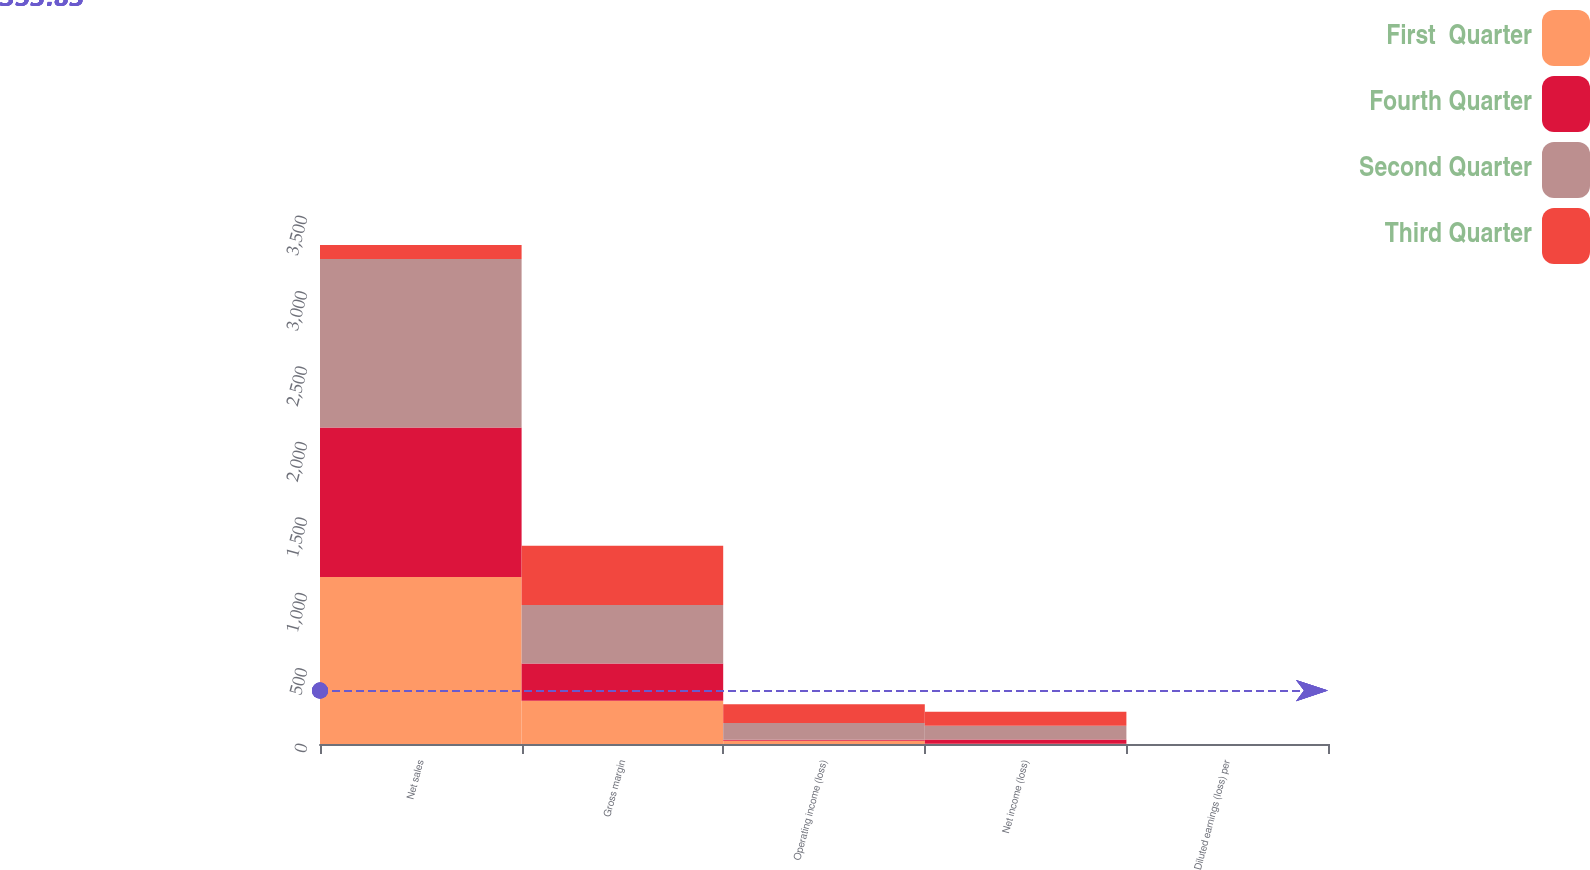<chart> <loc_0><loc_0><loc_500><loc_500><stacked_bar_chart><ecel><fcel>Net sales<fcel>Gross margin<fcel>Operating income (loss)<fcel>Net income (loss)<fcel>Diluted earnings (loss) per<nl><fcel>First  Quarter<fcel>1107.2<fcel>286<fcel>21.7<fcel>1.1<fcel>0<nl><fcel>Fourth Quarter<fcel>991<fcel>248.2<fcel>7.1<fcel>28.3<fcel>0.04<nl><fcel>Second Quarter<fcel>1116.8<fcel>387.9<fcel>109.7<fcel>90.9<fcel>0.13<nl><fcel>Third Quarter<fcel>93.5<fcel>392.6<fcel>125.4<fcel>93.5<fcel>0.14<nl></chart> 